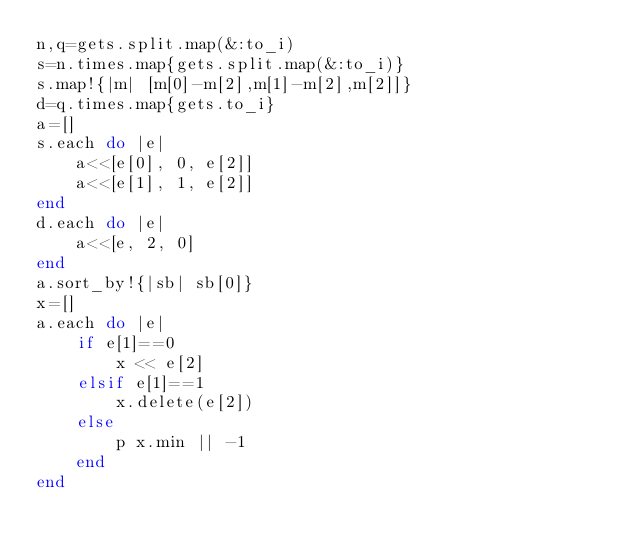<code> <loc_0><loc_0><loc_500><loc_500><_Ruby_>n,q=gets.split.map(&:to_i)
s=n.times.map{gets.split.map(&:to_i)}
s.map!{|m| [m[0]-m[2],m[1]-m[2],m[2]]}
d=q.times.map{gets.to_i}
a=[]
s.each do |e|
    a<<[e[0], 0, e[2]]
    a<<[e[1], 1, e[2]]
end
d.each do |e|
    a<<[e, 2, 0]
end
a.sort_by!{|sb| sb[0]}
x=[]
a.each do |e|
    if e[1]==0
        x << e[2]
    elsif e[1]==1
        x.delete(e[2])
    else
        p x.min || -1
    end
end</code> 